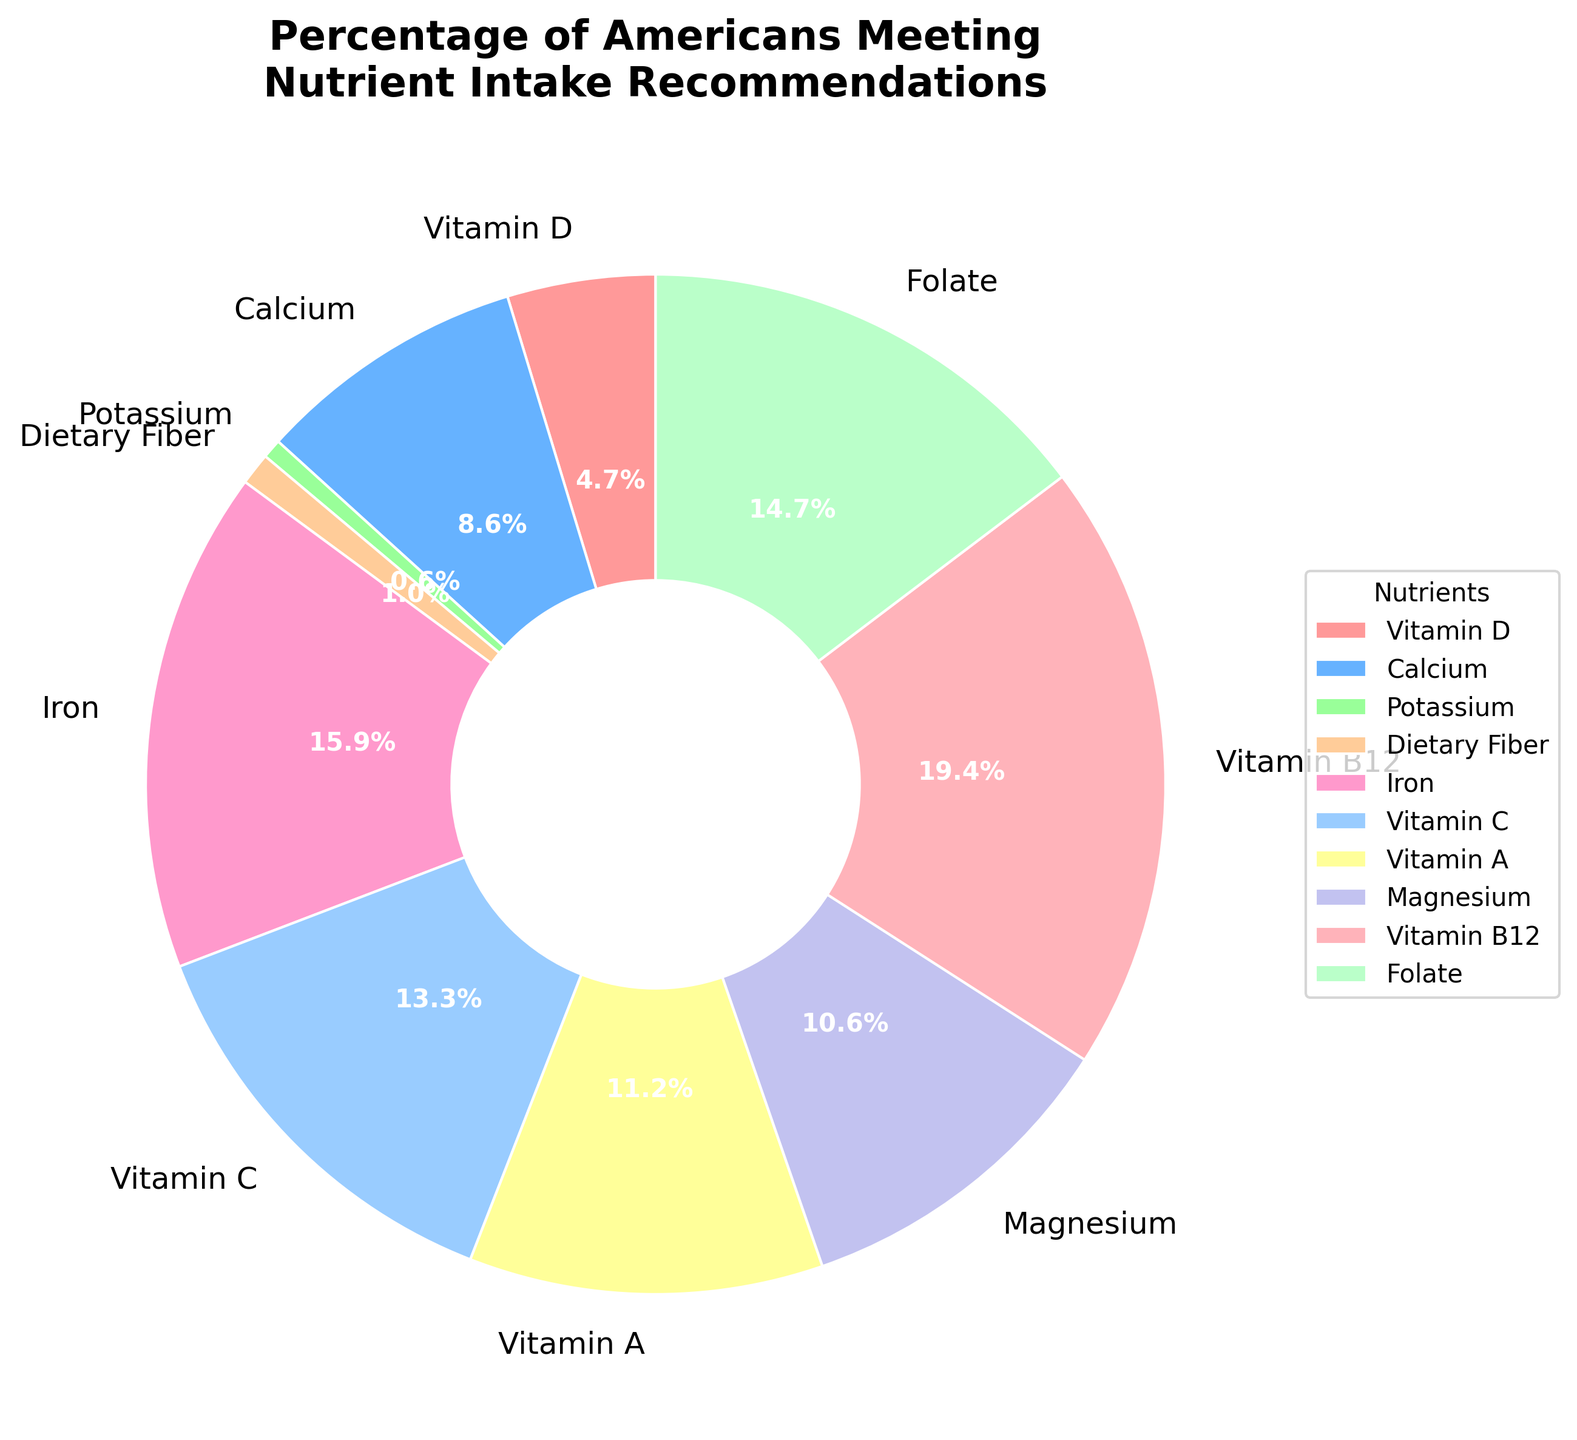Which nutrient has the lowest percentage of Americans meeting the intake recommendations? To determine which nutrient has the lowest percentage, check the pie chart for the smallest segment. The smallest segment is labeled as Potassium.
Answer: Potassium Which nutrient has the highest percentage of Americans meeting the intake recommendations? To identify the nutrient with the highest percentage, look for the largest segment in the pie chart. The largest segment is labeled as Vitamin B12.
Answer: Vitamin B12 How many nutrients have more than 50% of Americans meeting the intake recommendations? Examine the pie chart for segments with labels indicating percentages greater than 50%. There are Vitamin B12, Folate, Iron, Vitamin C, and Vitamin A.
Answer: 5 What is the percentage difference between Vitamin D and Vitamin B12? Subtract the percentage for Vitamin D (23%) from the percentage for Vitamin B12 (95%). The calculation is 95% - 23% = 72%.
Answer: 72% What is the combined percentage of Americans meeting the intake recommendations for Calcium and Magnesium? Add the percentages for Calcium (42%) and Magnesium (52%). The calculation is 42% + 52% = 94%.
Answer: 94% Is the percentage of Americans meeting Vitamin C recommendations greater or less than those meeting Iron recommendations? Compare the percentages for Vitamin C (65%) and Iron (78%). Vitamin C has a lower percentage.
Answer: Less Which nutrient depicted in the pie chart with a color closest to blue has its percentage represented? Identify the nutrient segment closest to blue in color and find its percentage. The nutrient closest to blue is Calcium (light blue), which is 42%.
Answer: Calcium Among Potassium, Dietary Fiber, and Vitamin D, which has the highest percentage of Americans meeting the intake recommendations? Compare the percentages of Potassium (3%), Dietary Fiber (5%), and Vitamin D (23%) to find the highest percentage. Vitamin D has the highest percentage.
Answer: Vitamin D What is the median percentage value among all the nutrients shown in the chart? List all the percentages in ascending order and find the middle value(s). The list is 3, 5, 23, 42, 52, 55, 65, 72, 78, 95. The median value is the average of the middle two percentages, which are 52 and 55, so (52 + 55) / 2 = 53.5.
Answer: 53.5 What is the visual attribute that distinguishes Vitamin B12 in the pie chart? Identify the visual characteristic corresponding to Vitamin B12. The pie chart shows that Vitamin B12 is represented by the largest segment.
Answer: Largest segment 